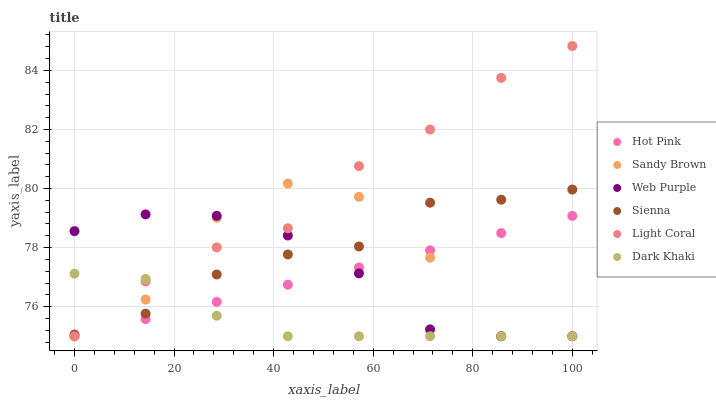Does Dark Khaki have the minimum area under the curve?
Answer yes or no. Yes. Does Light Coral have the maximum area under the curve?
Answer yes or no. Yes. Does Hot Pink have the minimum area under the curve?
Answer yes or no. No. Does Hot Pink have the maximum area under the curve?
Answer yes or no. No. Is Hot Pink the smoothest?
Answer yes or no. Yes. Is Sandy Brown the roughest?
Answer yes or no. Yes. Is Sienna the smoothest?
Answer yes or no. No. Is Sienna the roughest?
Answer yes or no. No. Does Light Coral have the lowest value?
Answer yes or no. Yes. Does Sienna have the lowest value?
Answer yes or no. No. Does Light Coral have the highest value?
Answer yes or no. Yes. Does Hot Pink have the highest value?
Answer yes or no. No. Is Hot Pink less than Sienna?
Answer yes or no. Yes. Is Sienna greater than Hot Pink?
Answer yes or no. Yes. Does Hot Pink intersect Dark Khaki?
Answer yes or no. Yes. Is Hot Pink less than Dark Khaki?
Answer yes or no. No. Is Hot Pink greater than Dark Khaki?
Answer yes or no. No. Does Hot Pink intersect Sienna?
Answer yes or no. No. 